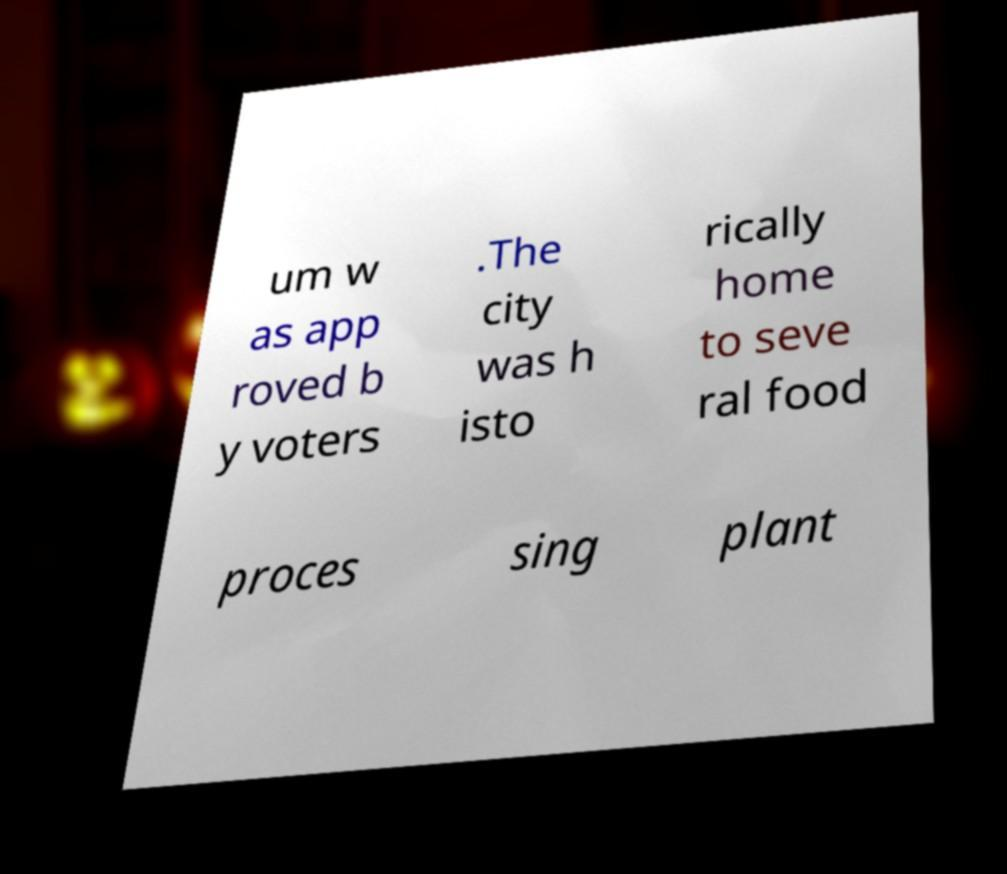Can you accurately transcribe the text from the provided image for me? um w as app roved b y voters .The city was h isto rically home to seve ral food proces sing plant 